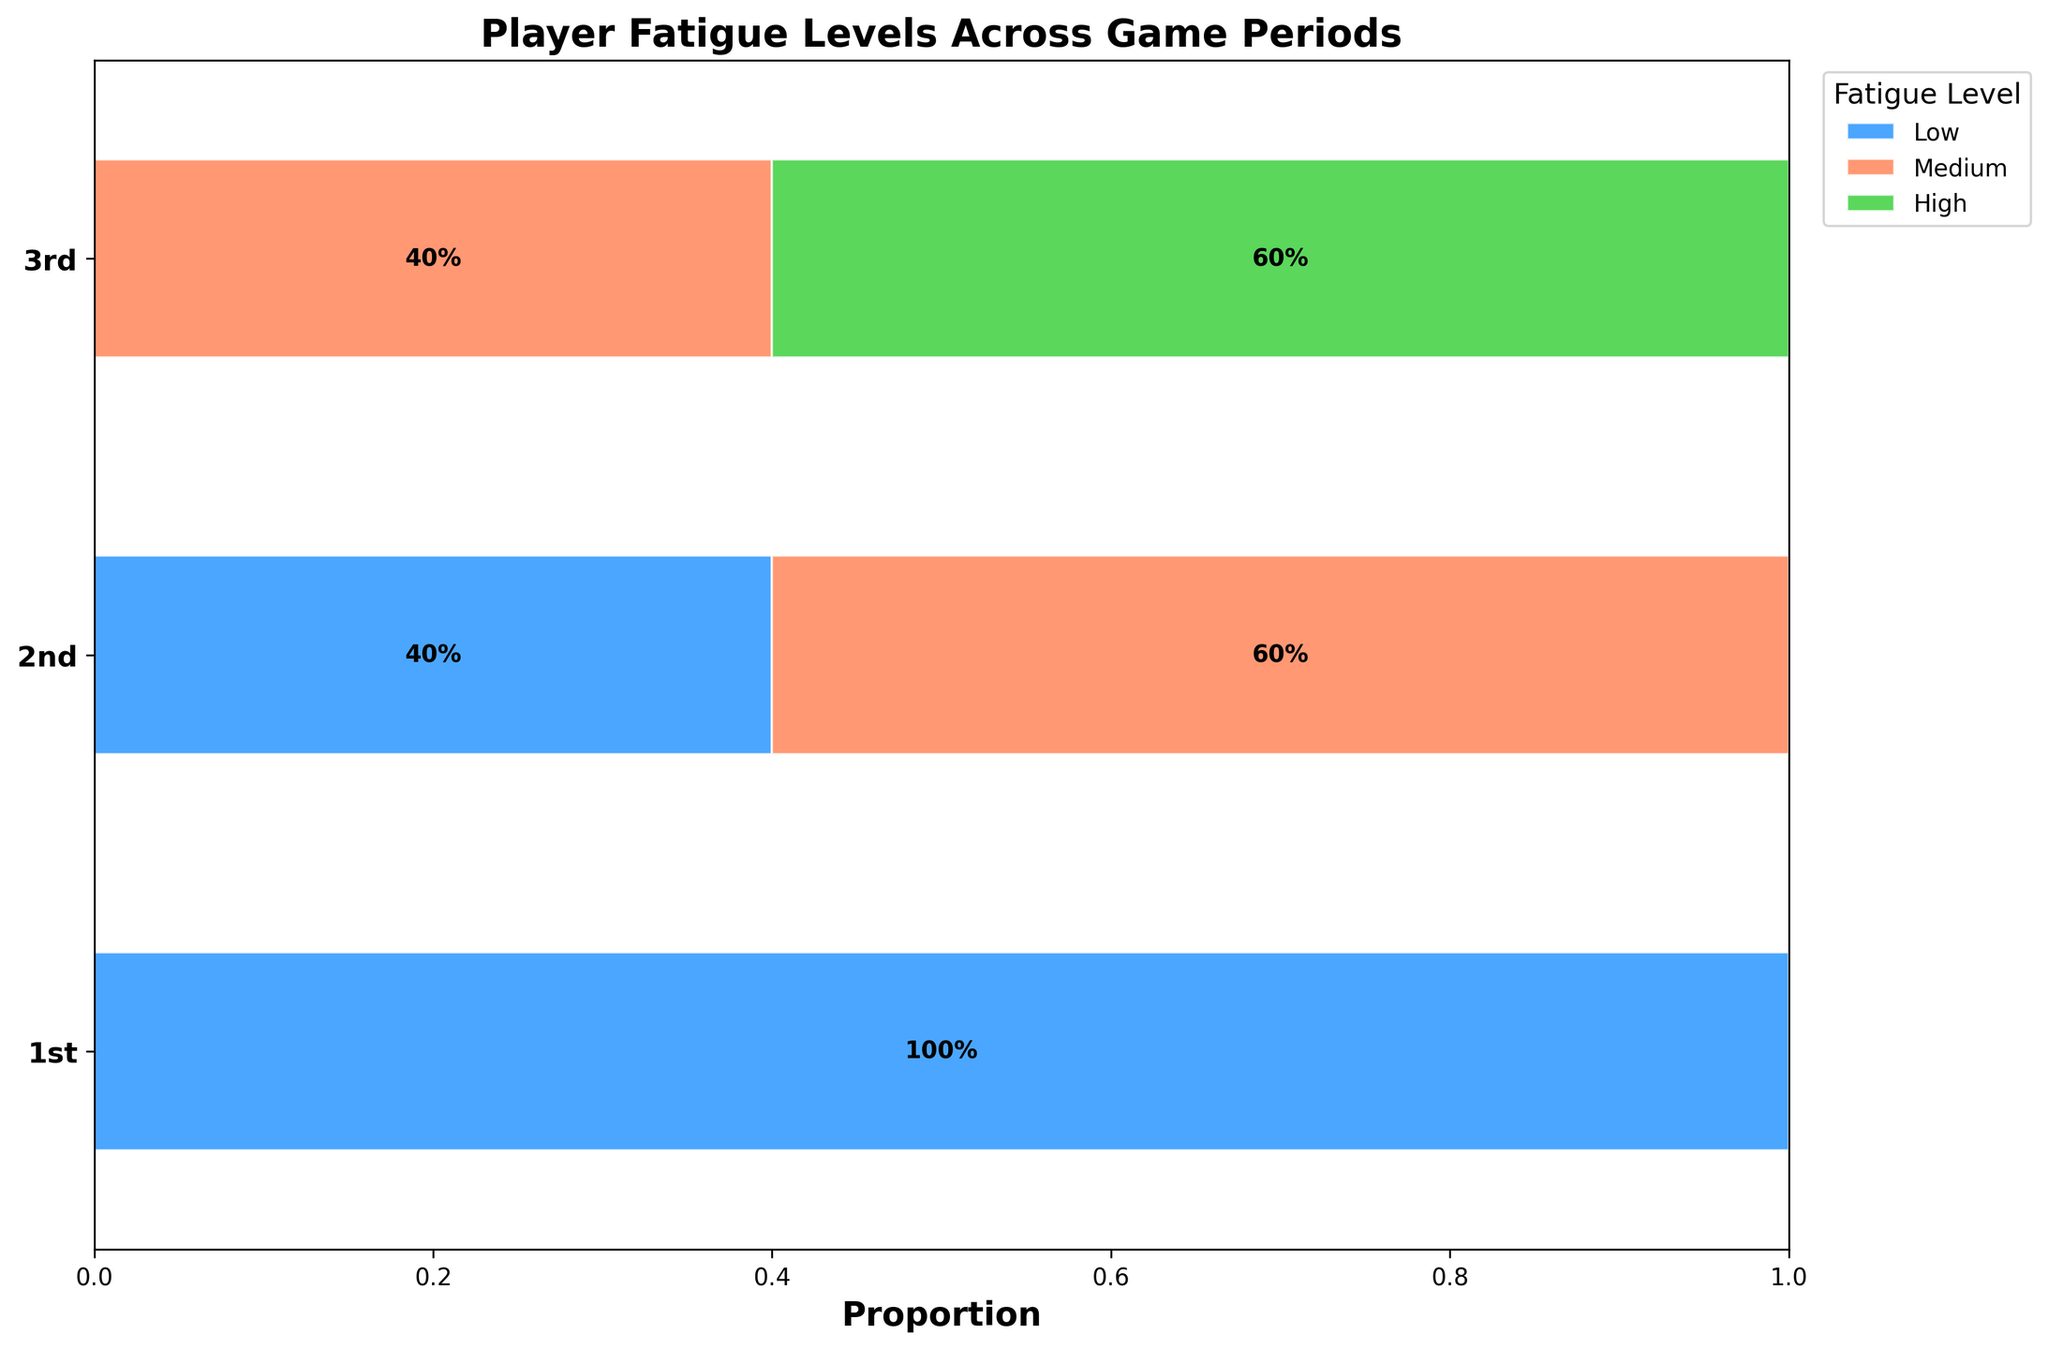What's the title of the figure? The title of the figure is prominent at the top and provides a summary of what the visual is about.
Answer: Player Fatigue Levels Across Game Periods How many periods are displayed in the figure? The periods are shown as separate rows on the y-axis of the figure.
Answer: 3 Which fatigue level has the largest proportion in the 1st period? By examining the widths of the bars representing different fatigue levels in the 1st period row, the widest bar corresponds to the "Low" fatigue level.
Answer: Low What's the percentage of players with medium fatigue in the 3rd period? The proportion label on the bar for medium fatigue in the 3rd period can be read directly off the figure.
Answer: 50% Compare the proportion of low fatigue players in the 1st and 2nd periods. Which one is higher? By comparing the width of the bars representing low fatigue in both 1st and 2nd periods, it is apparent that the 1st period has a wider bar indicating a higher proportion.
Answer: 1st period What is the combined percentage of players with high fatigue in the 2nd and 3rd periods? Sum the percentage labels from the high fatigue bars in the 2nd and 3rd periods. The 2nd period shows 25% and the 3rd period shows 50%.
Answer: 75% How does the proportion of medium fatigue levels change from the 1st to the 3rd period? Identify the medium fatigue proportions in each period and observe the changes: 0% in the 1st, increasing to 50% in the 3rd.
Answer: Increases Which period has the lowest proportion of high fatigue players? Examine the visual representation of high fatigue across the periods and identify the period with the smallest bar.
Answer: 1st period Among all periods, which fatigue level is never observed? By looking across all periods' bars, the proportion of medium fatigue for the 1st period is zero, indicating it never occurs in that period.
Answer: Medium in 1st period 